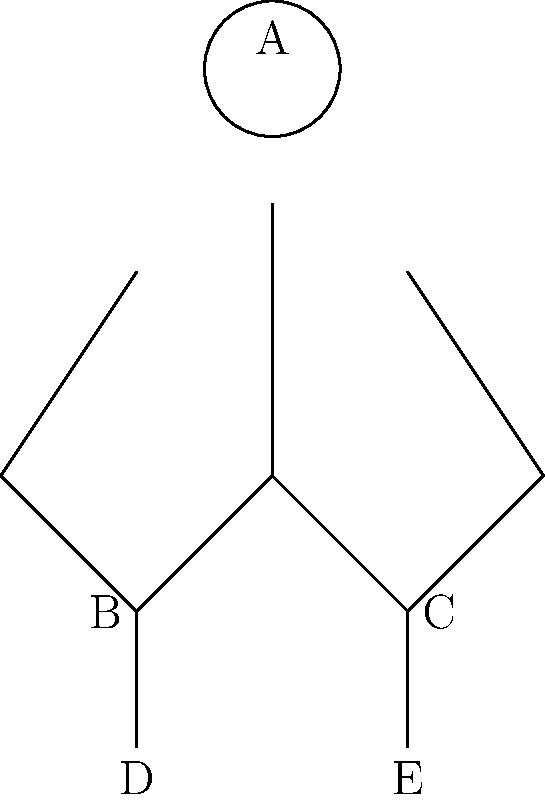In the stick figure diagram above, which represents the correct form for a bodyweight squat, what should be the relationship between points B, C, D, and E to ensure proper technique and balance? To determine the correct relationship between points B, C, D, and E for proper squat technique, let's follow these steps:

1. Identify the points:
   B: Left hand
   C: Right hand
   D: Left foot
   E: Right foot

2. Analyze the squat position:
   - The figure shows a person in a squat position with arms extended forward.

3. Consider proper squat form:
   - Feet should be shoulder-width apart or slightly wider.
   - Arms should be extended forward for balance.
   - Hands should be roughly in line with or slightly outside the feet.

4. Examine the horizontal alignment:
   - Points B and C (hands) should be approximately aligned with or slightly outside points D and E (feet).
   - This alignment helps maintain balance and proper form during the squat.

5. Consider vertical positioning:
   - Points B and C (hands) should be higher than points D and E (feet).
   - This position helps maintain an upright torso and prevents excessive forward lean.

6. Evaluate symmetry:
   - The distance between B and C should be similar to the distance between D and E.
   - This ensures a balanced and stable squat position.

Based on these considerations, the correct relationship between the points for proper squat technique is that B and C should form a line parallel to and slightly wider than the line formed by D and E, with B and C positioned higher than D and E.
Answer: B and C should form a line parallel to and slightly wider than D and E, positioned higher. 